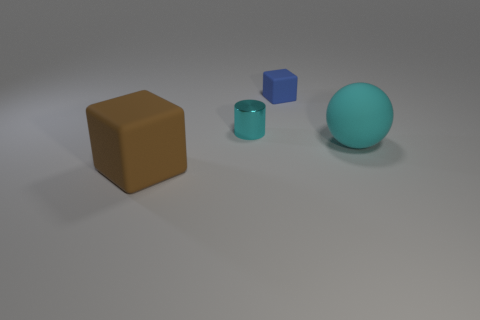There is a shiny cylinder; is it the same color as the tiny thing to the right of the cylinder?
Offer a terse response. No. Is the number of large matte balls to the left of the sphere greater than the number of cyan shiny cylinders?
Provide a succinct answer. No. What number of small metallic cylinders are behind the matte block that is behind the matte block that is to the left of the tiny blue matte object?
Your response must be concise. 0. There is a large thing that is in front of the big cyan matte sphere; is its shape the same as the tiny blue object?
Provide a short and direct response. Yes. There is a cyan object that is behind the big cyan ball; what is it made of?
Keep it short and to the point. Metal. What shape is the matte object that is both on the left side of the ball and in front of the blue thing?
Your answer should be very brief. Cube. What is the large brown object made of?
Offer a terse response. Rubber. What number of blocks are either big blue matte objects or brown objects?
Give a very brief answer. 1. Do the tiny cyan object and the brown object have the same material?
Give a very brief answer. No. The brown matte thing that is the same shape as the tiny blue matte object is what size?
Provide a succinct answer. Large. 